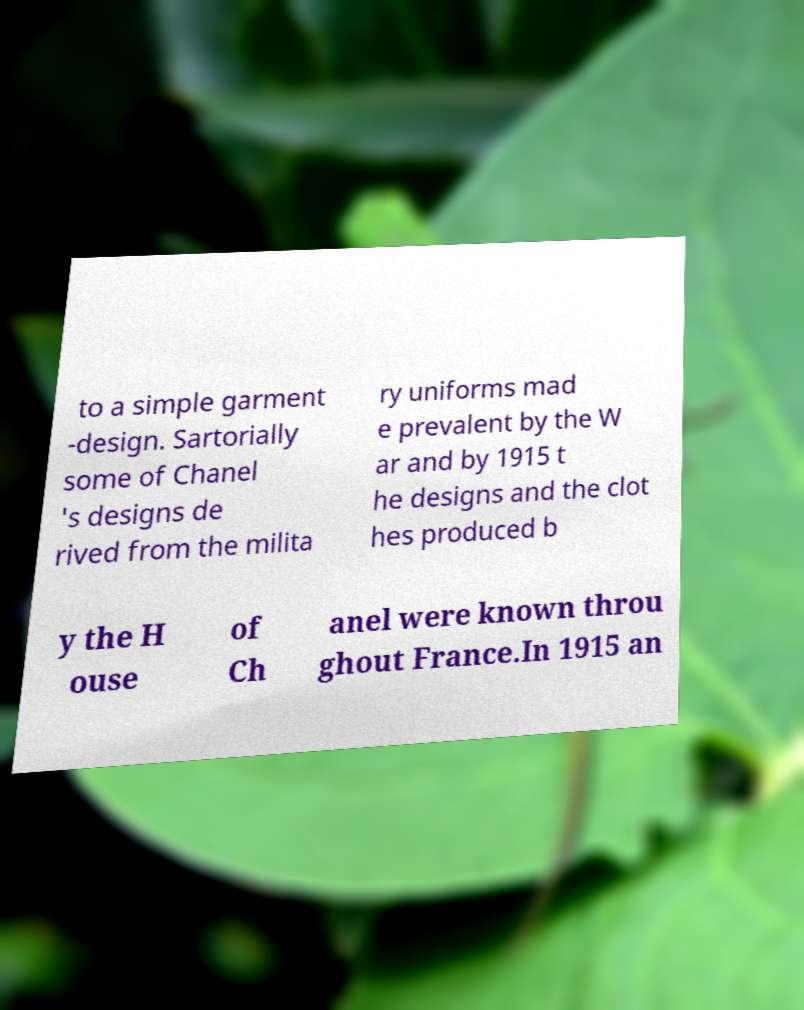Could you assist in decoding the text presented in this image and type it out clearly? to a simple garment -design. Sartorially some of Chanel 's designs de rived from the milita ry uniforms mad e prevalent by the W ar and by 1915 t he designs and the clot hes produced b y the H ouse of Ch anel were known throu ghout France.In 1915 an 